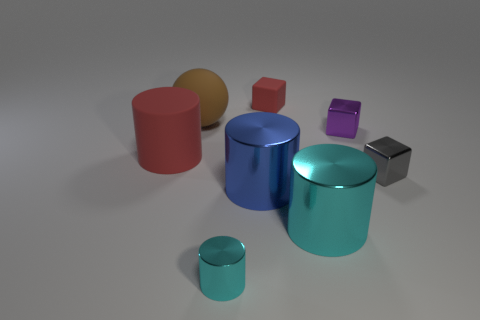Subtract all brown cubes. How many cyan cylinders are left? 2 Subtract all blue cylinders. How many cylinders are left? 3 Subtract all blue cylinders. How many cylinders are left? 3 Add 2 tiny gray metallic blocks. How many objects exist? 10 Subtract all cubes. How many objects are left? 5 Subtract all gray cylinders. Subtract all yellow spheres. How many cylinders are left? 4 Subtract all small red blocks. Subtract all tiny cyan cylinders. How many objects are left? 6 Add 6 red matte cubes. How many red matte cubes are left? 7 Add 8 red blocks. How many red blocks exist? 9 Subtract 1 brown balls. How many objects are left? 7 